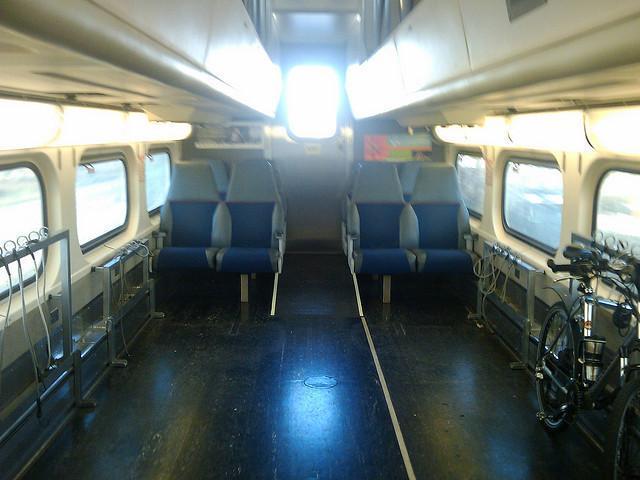How many people are on the train?
Give a very brief answer. 0. How many seats are on the bus?
Give a very brief answer. 8. How many chairs are in the picture?
Give a very brief answer. 4. How many clocks on the tower?
Give a very brief answer. 0. 